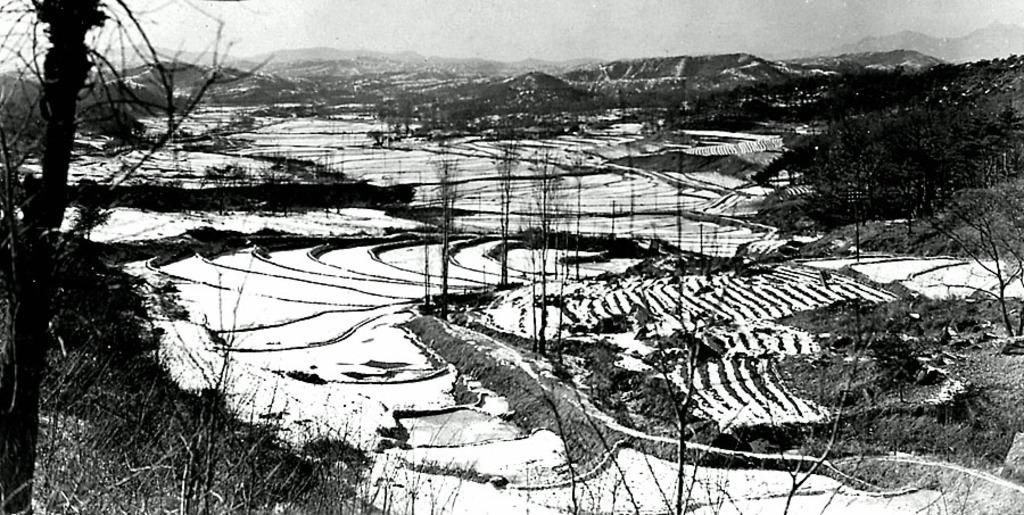What type of vegetation can be seen in the image? There are trees in the image. What is covering the ground in the image? There is snow and grass in the image. What type of geographical feature is visible in the image? There are mountains in the image. What can be seen in the background of the image? The sky is visible in the background of the image. How many socks are hanging on the trees in the image? There are no socks present in the image; it features trees, snow, grass, mountains, and a visible sky. 